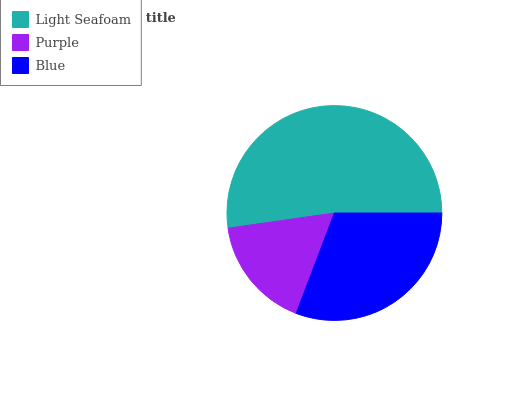Is Purple the minimum?
Answer yes or no. Yes. Is Light Seafoam the maximum?
Answer yes or no. Yes. Is Blue the minimum?
Answer yes or no. No. Is Blue the maximum?
Answer yes or no. No. Is Blue greater than Purple?
Answer yes or no. Yes. Is Purple less than Blue?
Answer yes or no. Yes. Is Purple greater than Blue?
Answer yes or no. No. Is Blue less than Purple?
Answer yes or no. No. Is Blue the high median?
Answer yes or no. Yes. Is Blue the low median?
Answer yes or no. Yes. Is Light Seafoam the high median?
Answer yes or no. No. Is Purple the low median?
Answer yes or no. No. 